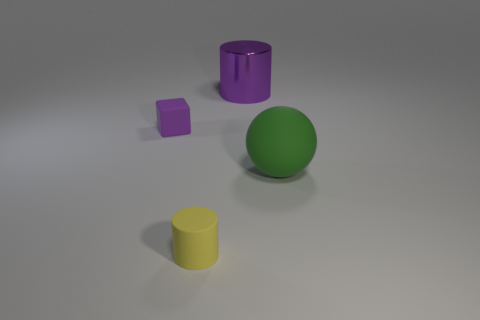Is there anything else that is the same shape as the purple rubber thing?
Make the answer very short. No. There is a small thing that is left of the small yellow object; what is it made of?
Keep it short and to the point. Rubber. Does the big purple metallic object have the same shape as the small thing that is in front of the large green sphere?
Your answer should be compact. Yes. The object that is both to the right of the purple rubber cube and left of the metal thing is made of what material?
Ensure brevity in your answer.  Rubber. There is a rubber cylinder that is the same size as the purple rubber thing; what color is it?
Your response must be concise. Yellow. Are the small purple block and the cylinder to the right of the yellow matte object made of the same material?
Keep it short and to the point. No. What number of other things are the same size as the rubber cylinder?
Offer a terse response. 1. There is a purple object that is in front of the cylinder that is on the right side of the small yellow cylinder; are there any matte objects that are on the left side of it?
Offer a terse response. No. What size is the purple rubber block?
Your response must be concise. Small. There is a cylinder in front of the big metallic thing; what is its size?
Your answer should be compact. Small. 